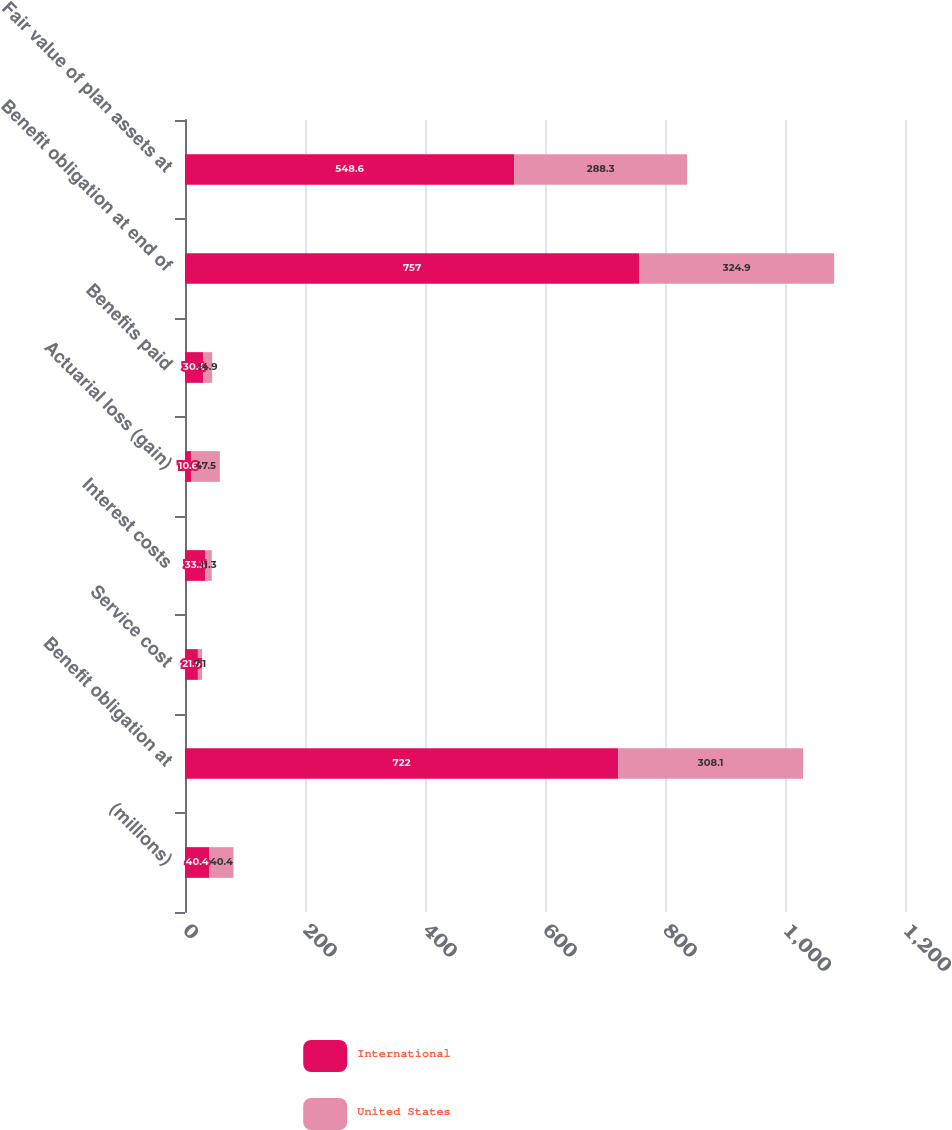Convert chart to OTSL. <chart><loc_0><loc_0><loc_500><loc_500><stacked_bar_chart><ecel><fcel>(millions)<fcel>Benefit obligation at<fcel>Service cost<fcel>Interest costs<fcel>Actuarial loss (gain)<fcel>Benefits paid<fcel>Benefit obligation at end of<fcel>Fair value of plan assets at<nl><fcel>International<fcel>40.4<fcel>722<fcel>21.5<fcel>33.3<fcel>10.6<fcel>30.4<fcel>757<fcel>548.6<nl><fcel>United States<fcel>40.4<fcel>308.1<fcel>7.1<fcel>11.3<fcel>47.5<fcel>14.9<fcel>324.9<fcel>288.3<nl></chart> 